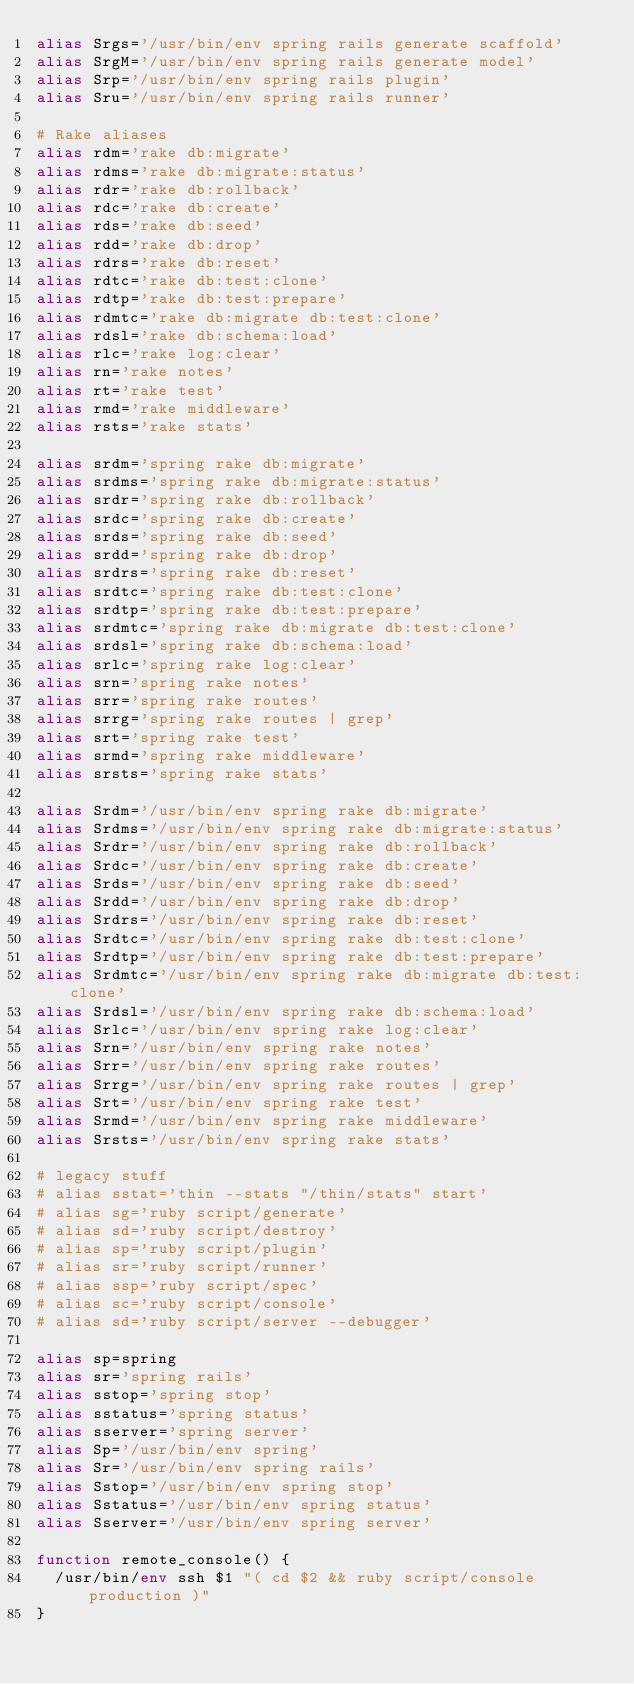Convert code to text. <code><loc_0><loc_0><loc_500><loc_500><_Bash_>alias Srgs='/usr/bin/env spring rails generate scaffold'
alias SrgM='/usr/bin/env spring rails generate model'
alias Srp='/usr/bin/env spring rails plugin'
alias Sru='/usr/bin/env spring rails runner'

# Rake aliases
alias rdm='rake db:migrate'
alias rdms='rake db:migrate:status'
alias rdr='rake db:rollback'
alias rdc='rake db:create'
alias rds='rake db:seed'
alias rdd='rake db:drop'
alias rdrs='rake db:reset'
alias rdtc='rake db:test:clone'
alias rdtp='rake db:test:prepare'
alias rdmtc='rake db:migrate db:test:clone'
alias rdsl='rake db:schema:load'
alias rlc='rake log:clear'
alias rn='rake notes'
alias rt='rake test'
alias rmd='rake middleware'
alias rsts='rake stats'

alias srdm='spring rake db:migrate'
alias srdms='spring rake db:migrate:status'
alias srdr='spring rake db:rollback'
alias srdc='spring rake db:create'
alias srds='spring rake db:seed'
alias srdd='spring rake db:drop'
alias srdrs='spring rake db:reset'
alias srdtc='spring rake db:test:clone'
alias srdtp='spring rake db:test:prepare'
alias srdmtc='spring rake db:migrate db:test:clone'
alias srdsl='spring rake db:schema:load'
alias srlc='spring rake log:clear'
alias srn='spring rake notes'
alias srr='spring rake routes'
alias srrg='spring rake routes | grep'
alias srt='spring rake test'
alias srmd='spring rake middleware'
alias srsts='spring rake stats'

alias Srdm='/usr/bin/env spring rake db:migrate'
alias Srdms='/usr/bin/env spring rake db:migrate:status'
alias Srdr='/usr/bin/env spring rake db:rollback'
alias Srdc='/usr/bin/env spring rake db:create'
alias Srds='/usr/bin/env spring rake db:seed'
alias Srdd='/usr/bin/env spring rake db:drop'
alias Srdrs='/usr/bin/env spring rake db:reset'
alias Srdtc='/usr/bin/env spring rake db:test:clone'
alias Srdtp='/usr/bin/env spring rake db:test:prepare'
alias Srdmtc='/usr/bin/env spring rake db:migrate db:test:clone'
alias Srdsl='/usr/bin/env spring rake db:schema:load'
alias Srlc='/usr/bin/env spring rake log:clear'
alias Srn='/usr/bin/env spring rake notes'
alias Srr='/usr/bin/env spring rake routes'
alias Srrg='/usr/bin/env spring rake routes | grep'
alias Srt='/usr/bin/env spring rake test'
alias Srmd='/usr/bin/env spring rake middleware'
alias Srsts='/usr/bin/env spring rake stats'

# legacy stuff
# alias sstat='thin --stats "/thin/stats" start'
# alias sg='ruby script/generate'
# alias sd='ruby script/destroy'
# alias sp='ruby script/plugin'
# alias sr='ruby script/runner'
# alias ssp='ruby script/spec'
# alias sc='ruby script/console'
# alias sd='ruby script/server --debugger'

alias sp=spring
alias sr='spring rails'
alias sstop='spring stop'
alias sstatus='spring status'
alias sserver='spring server'
alias Sp='/usr/bin/env spring'
alias Sr='/usr/bin/env spring rails'
alias Sstop='/usr/bin/env spring stop'
alias Sstatus='/usr/bin/env spring status'
alias Sserver='/usr/bin/env spring server'

function remote_console() {
  /usr/bin/env ssh $1 "( cd $2 && ruby script/console production )"
}
</code> 